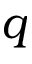<formula> <loc_0><loc_0><loc_500><loc_500>q</formula> 